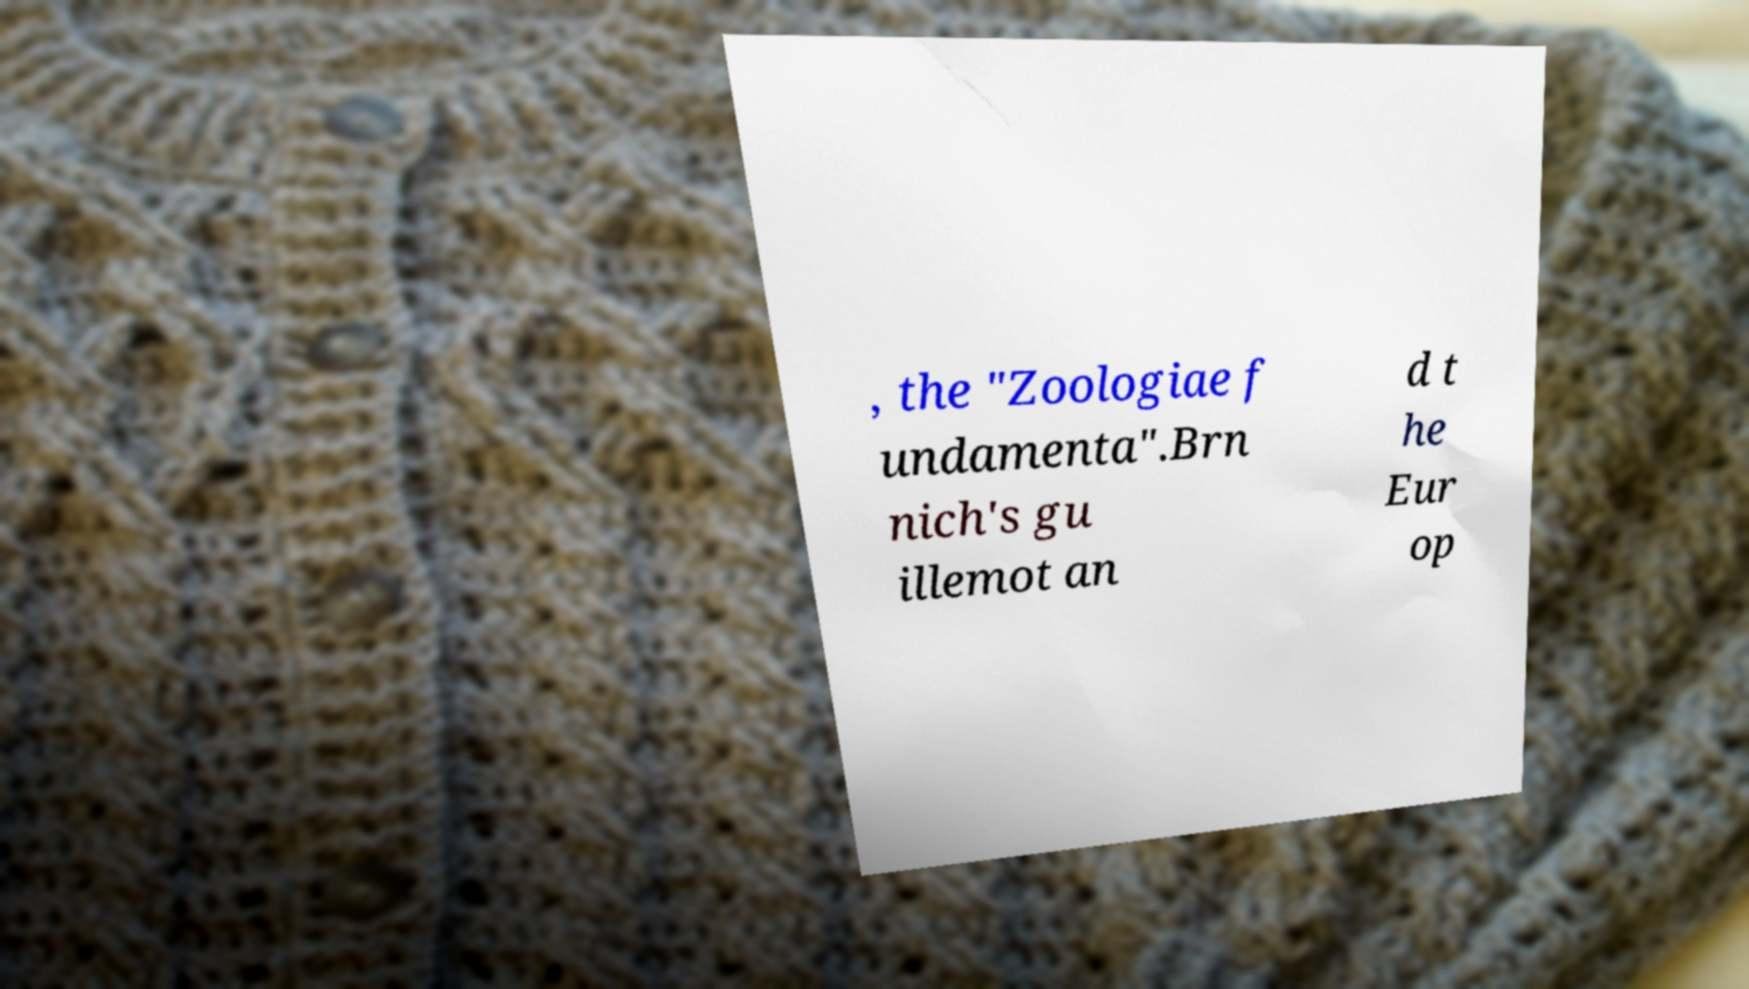I need the written content from this picture converted into text. Can you do that? , the "Zoologiae f undamenta".Brn nich's gu illemot an d t he Eur op 